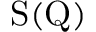<formula> <loc_0><loc_0><loc_500><loc_500>S ( Q )</formula> 